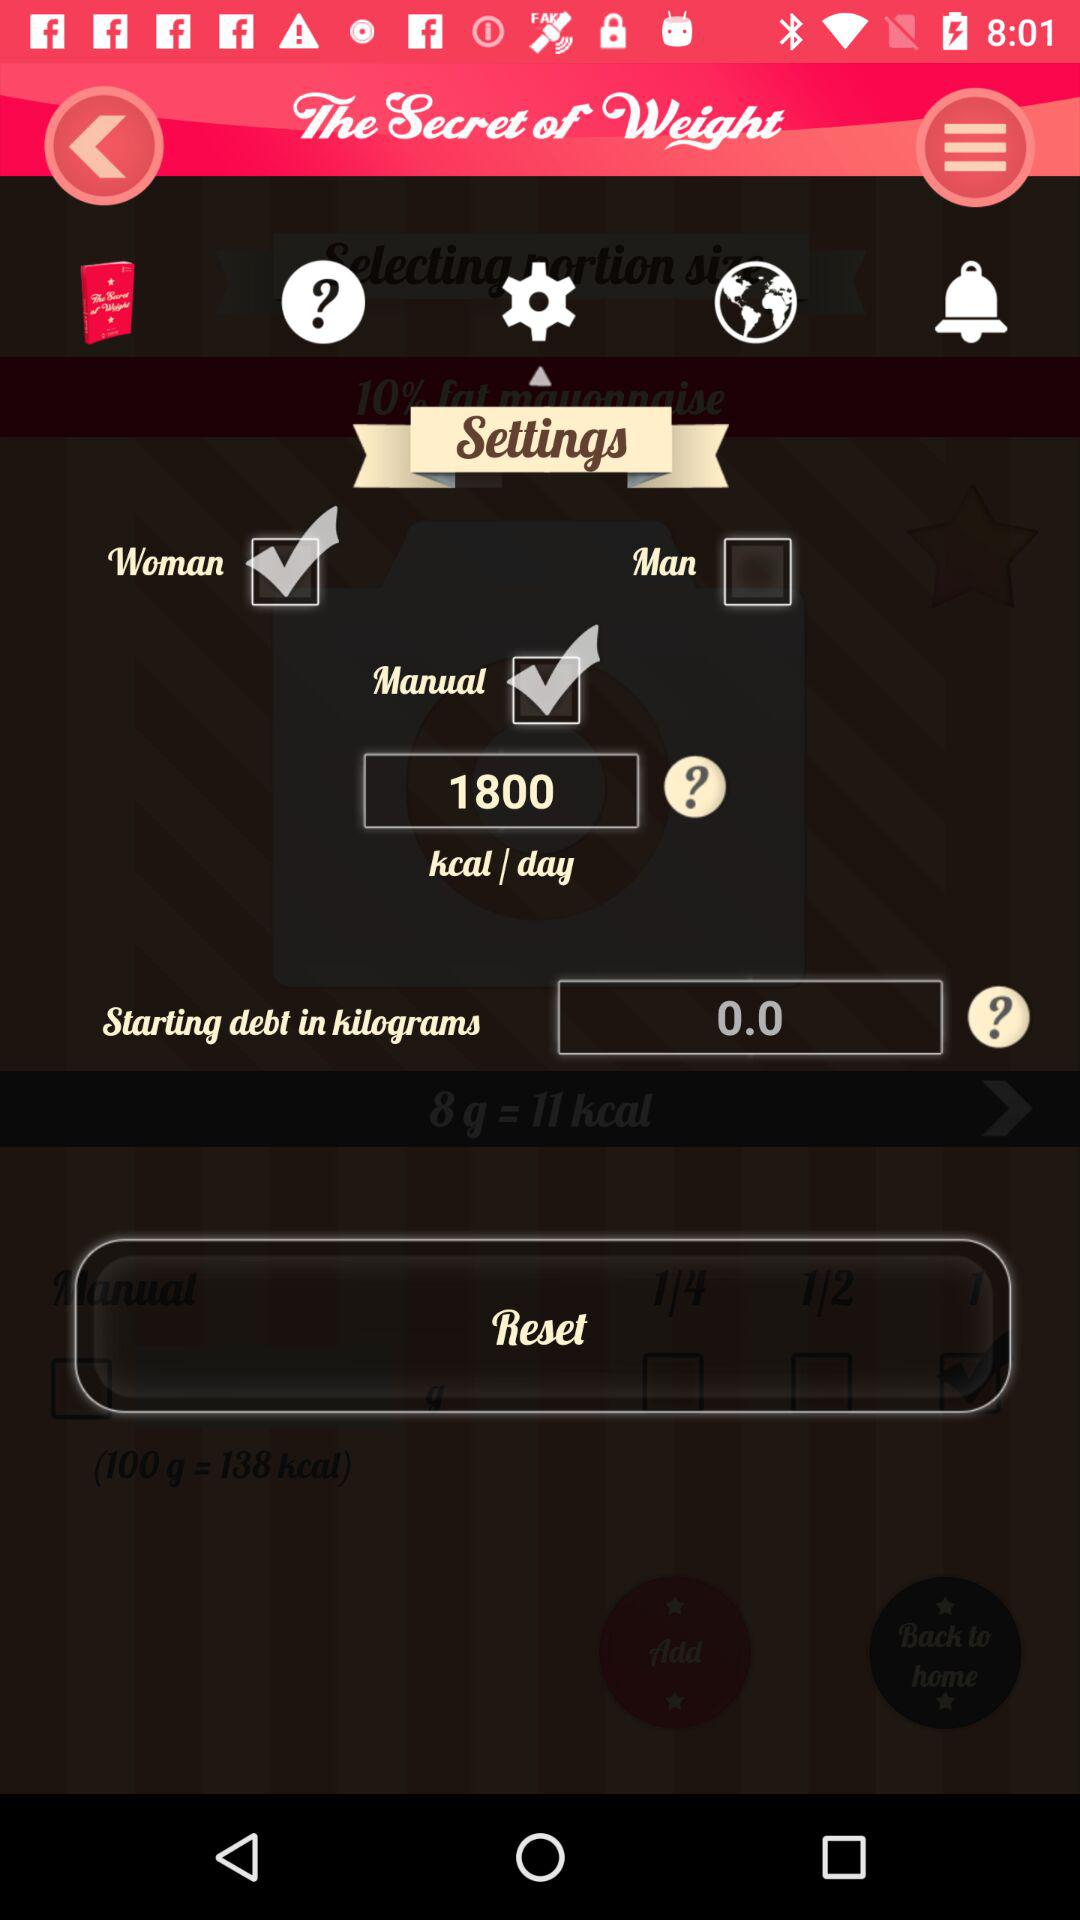How many kilocalories per day are mentioned? The mentioned kilocalories per day are 1800. 